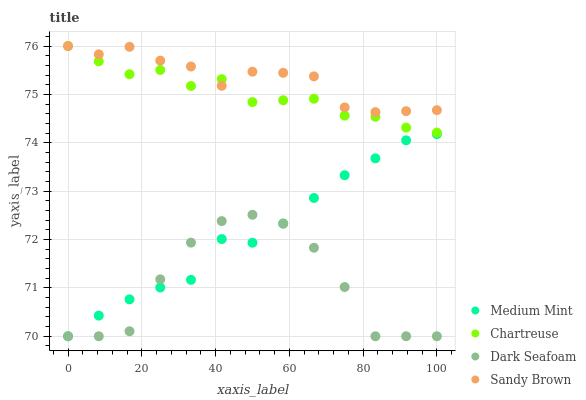Does Dark Seafoam have the minimum area under the curve?
Answer yes or no. Yes. Does Sandy Brown have the maximum area under the curve?
Answer yes or no. Yes. Does Chartreuse have the minimum area under the curve?
Answer yes or no. No. Does Chartreuse have the maximum area under the curve?
Answer yes or no. No. Is Medium Mint the smoothest?
Answer yes or no. Yes. Is Dark Seafoam the roughest?
Answer yes or no. Yes. Is Chartreuse the smoothest?
Answer yes or no. No. Is Chartreuse the roughest?
Answer yes or no. No. Does Medium Mint have the lowest value?
Answer yes or no. Yes. Does Chartreuse have the lowest value?
Answer yes or no. No. Does Sandy Brown have the highest value?
Answer yes or no. Yes. Does Dark Seafoam have the highest value?
Answer yes or no. No. Is Dark Seafoam less than Chartreuse?
Answer yes or no. Yes. Is Sandy Brown greater than Medium Mint?
Answer yes or no. Yes. Does Medium Mint intersect Dark Seafoam?
Answer yes or no. Yes. Is Medium Mint less than Dark Seafoam?
Answer yes or no. No. Is Medium Mint greater than Dark Seafoam?
Answer yes or no. No. Does Dark Seafoam intersect Chartreuse?
Answer yes or no. No. 